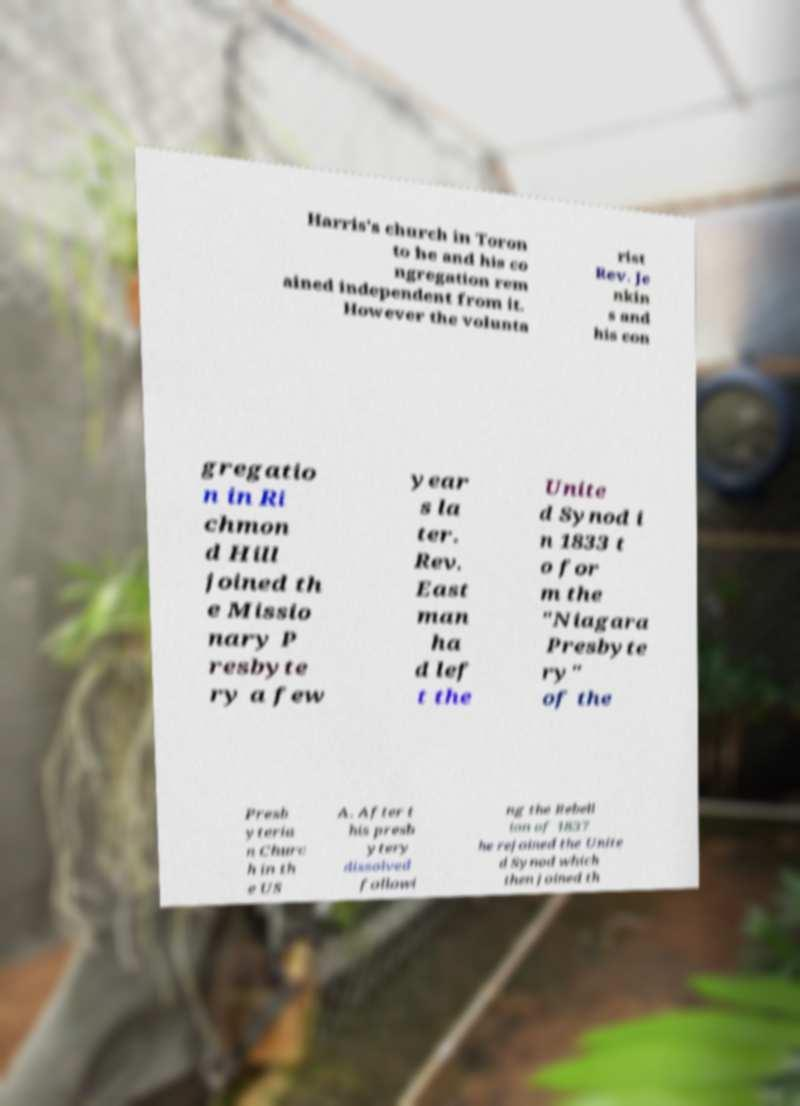Can you read and provide the text displayed in the image?This photo seems to have some interesting text. Can you extract and type it out for me? Harris's church in Toron to he and his co ngregation rem ained independent from it. However the volunta rist Rev. Je nkin s and his con gregatio n in Ri chmon d Hill joined th e Missio nary P resbyte ry a few year s la ter. Rev. East man ha d lef t the Unite d Synod i n 1833 t o for m the "Niagara Presbyte ry" of the Presb yteria n Churc h in th e US A. After t his presb ytery dissolved followi ng the Rebell ion of 1837 he rejoined the Unite d Synod which then joined th 